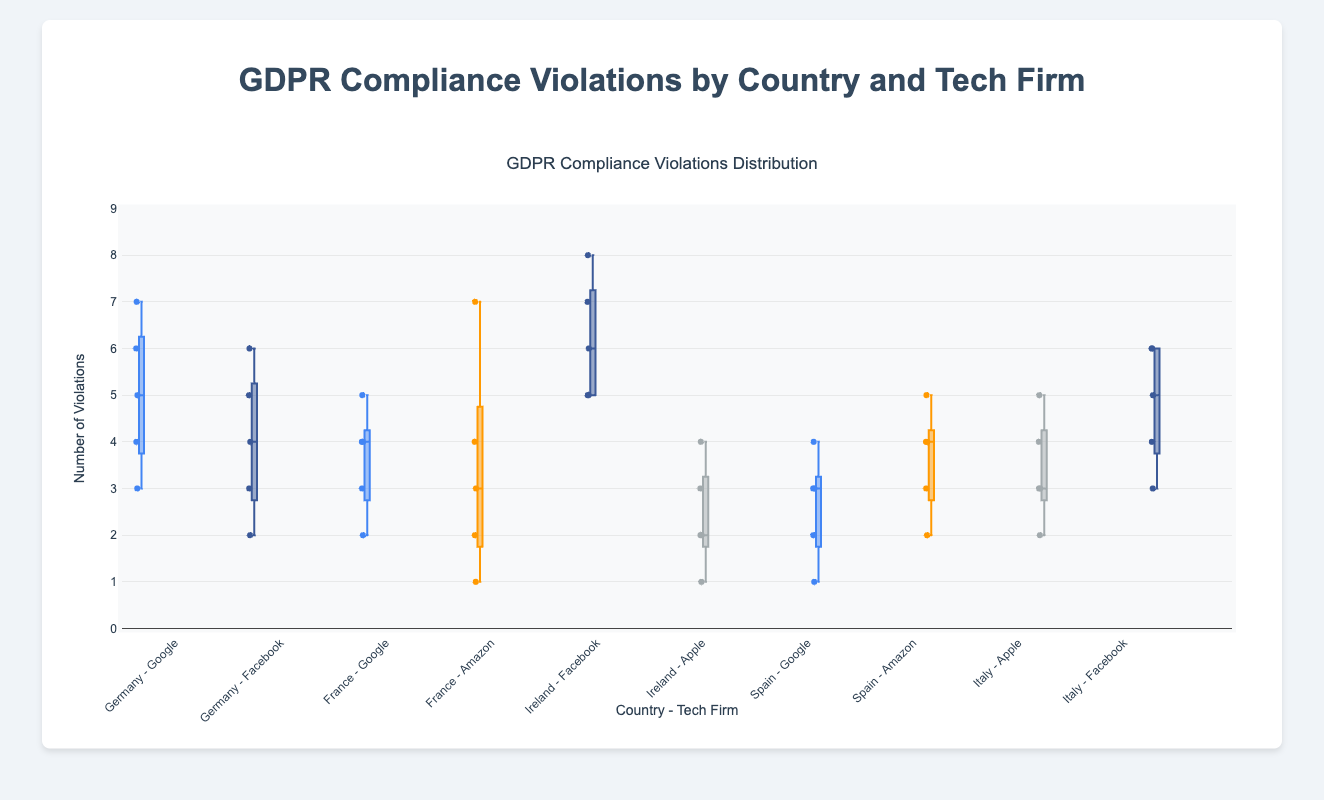How many different countries are represented in the plot? The title indicates that the plot is about GDPR compliance violations by country and tech firm. To determine the number of countries, observe the x-axis labels. Each country-firm combination is listed, and we can see Germany, France, Ireland, Spain, and Italy. Thus, we have 5 different countries.
Answer: 5 What's the median number of GDPR violations for Google in Germany? The box plot shows the distribution of violations. The median is represented by the line within the box. For Google in Germany, the violations data are [5, 3, 6, 4, 7]. Arranging them in ascending order [3, 4, 5, 6, 7], the median is the middle value, which is 5.
Answer: 5 Which country-tech firm combination has the highest maximum number of GDPR violations? The maximum number of GDPR violations is represented by the upper whisker or the highest individual point in each box plot. Looking at all the box plots, we find that Ireland - Facebook had the highest maximum number of violations, which is 8.
Answer: Ireland - Facebook Compare the spread of violations for Amazon in France and Spain. Which one has a larger spread? The spread of a box plot can be determined by the distance between the first quartile (lower boundary of the box) and the third quartile (upper boundary of the box). For Amazon in France, the range is from 2 to 4.5 approximately. For Amazon in Spain, the range is from 2 to 4. Therefore, France has a larger spread.
Answer: France What is the interquartile range (IQR) for Apple in Ireland? The IQR is the difference between the third quartile (Q3) and the first quartile (Q1). For Apple in Ireland, the box plot shows that Q1 is around 2 and Q3 is around 3. The IQR is Q3 - Q1 = 3 - 2 = 1.
Answer: 1 Which firm in Germany has a lower median number of violations? From the box plots for Germany, observe the medians. Google has a median of 5, while Facebook has a median of 4. Therefore, Facebook has a lower median number of violations.
Answer: Facebook How does the variability of GDPR violations for Apple in Italy compare to that in Ireland? Variability in a box plot can be assessed based on the interquartile range (IQR). For Apple, Italy's IQR seems larger. Italy's violations spread from 3 to 4 (difference of 1), while Ireland spreads from about 1.5 to 3 (difference of 1.5). Thus, variability looks a bit more in Ireland compared to Italy.
Answer: Ireland Are there any country-firm combinations where the violation count never exceeds 5? Looking at the maximum values (upper whiskers) of the box plots, the combinations are: Apple - Ireland (max 4), Spain - Google (max 4), and France - Google (max 5). Based on the visualization and identified maximums, Apple in Ireland has violations not going beyond 4.
Answer: Apple - Ireland Which tech firm in Italy has a higher overall range of violations? The overall range is measured from the minimum to the maximum value on the y-axis. For Apple, the range goes from around 2 to 5. For Facebook, the range goes from 3 to 6. Hence, Facebook has a wider range.
Answer: Facebook 